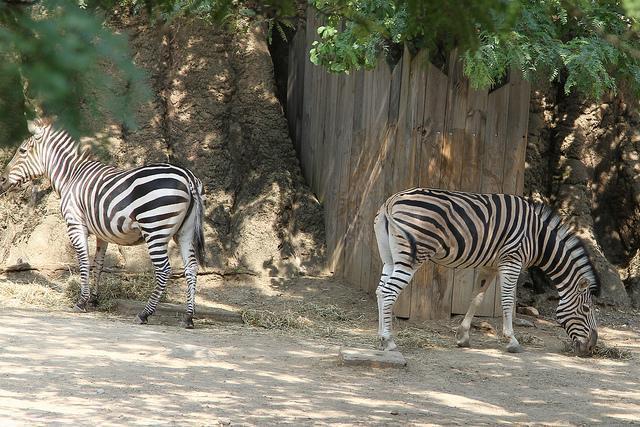How many zebras are there?
Give a very brief answer. 2. How many zebras can you see?
Give a very brief answer. 2. 